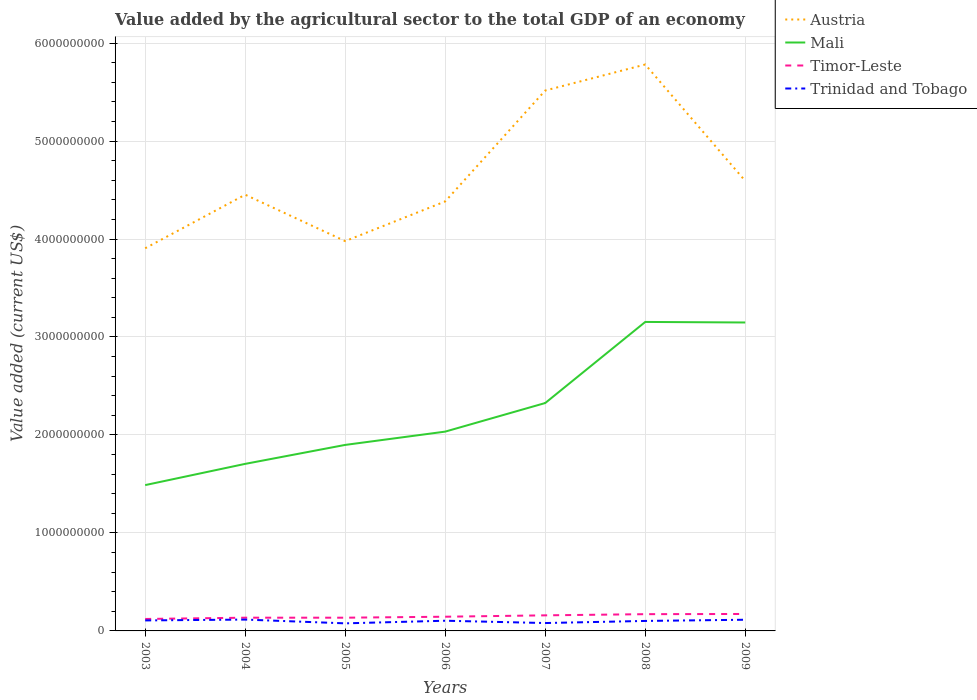How many different coloured lines are there?
Keep it short and to the point. 4. Does the line corresponding to Trinidad and Tobago intersect with the line corresponding to Timor-Leste?
Make the answer very short. No. Is the number of lines equal to the number of legend labels?
Your response must be concise. Yes. Across all years, what is the maximum value added by the agricultural sector to the total GDP in Timor-Leste?
Provide a short and direct response. 1.22e+08. In which year was the value added by the agricultural sector to the total GDP in Austria maximum?
Ensure brevity in your answer.  2003. What is the total value added by the agricultural sector to the total GDP in Austria in the graph?
Keep it short and to the point. -4.05e+08. What is the difference between the highest and the second highest value added by the agricultural sector to the total GDP in Mali?
Make the answer very short. 1.67e+09. Is the value added by the agricultural sector to the total GDP in Trinidad and Tobago strictly greater than the value added by the agricultural sector to the total GDP in Austria over the years?
Your answer should be compact. Yes. How many lines are there?
Ensure brevity in your answer.  4. Are the values on the major ticks of Y-axis written in scientific E-notation?
Your answer should be compact. No. Does the graph contain grids?
Keep it short and to the point. Yes. How many legend labels are there?
Your response must be concise. 4. What is the title of the graph?
Provide a short and direct response. Value added by the agricultural sector to the total GDP of an economy. Does "Greenland" appear as one of the legend labels in the graph?
Offer a very short reply. No. What is the label or title of the X-axis?
Make the answer very short. Years. What is the label or title of the Y-axis?
Keep it short and to the point. Value added (current US$). What is the Value added (current US$) in Austria in 2003?
Keep it short and to the point. 3.91e+09. What is the Value added (current US$) of Mali in 2003?
Your response must be concise. 1.49e+09. What is the Value added (current US$) in Timor-Leste in 2003?
Your answer should be very brief. 1.22e+08. What is the Value added (current US$) of Trinidad and Tobago in 2003?
Make the answer very short. 1.07e+08. What is the Value added (current US$) in Austria in 2004?
Your response must be concise. 4.45e+09. What is the Value added (current US$) of Mali in 2004?
Your answer should be very brief. 1.71e+09. What is the Value added (current US$) of Timor-Leste in 2004?
Provide a succinct answer. 1.35e+08. What is the Value added (current US$) of Trinidad and Tobago in 2004?
Ensure brevity in your answer.  1.16e+08. What is the Value added (current US$) of Austria in 2005?
Offer a terse response. 3.98e+09. What is the Value added (current US$) of Mali in 2005?
Give a very brief answer. 1.90e+09. What is the Value added (current US$) in Timor-Leste in 2005?
Your response must be concise. 1.35e+08. What is the Value added (current US$) in Trinidad and Tobago in 2005?
Provide a short and direct response. 7.73e+07. What is the Value added (current US$) in Austria in 2006?
Your response must be concise. 4.38e+09. What is the Value added (current US$) of Mali in 2006?
Provide a succinct answer. 2.03e+09. What is the Value added (current US$) of Timor-Leste in 2006?
Your answer should be very brief. 1.45e+08. What is the Value added (current US$) in Trinidad and Tobago in 2006?
Your answer should be very brief. 1.04e+08. What is the Value added (current US$) of Austria in 2007?
Give a very brief answer. 5.52e+09. What is the Value added (current US$) of Mali in 2007?
Offer a very short reply. 2.33e+09. What is the Value added (current US$) of Timor-Leste in 2007?
Keep it short and to the point. 1.59e+08. What is the Value added (current US$) in Trinidad and Tobago in 2007?
Keep it short and to the point. 8.04e+07. What is the Value added (current US$) of Austria in 2008?
Give a very brief answer. 5.78e+09. What is the Value added (current US$) of Mali in 2008?
Ensure brevity in your answer.  3.15e+09. What is the Value added (current US$) in Timor-Leste in 2008?
Make the answer very short. 1.71e+08. What is the Value added (current US$) of Trinidad and Tobago in 2008?
Your answer should be compact. 1.02e+08. What is the Value added (current US$) of Austria in 2009?
Your answer should be very brief. 4.59e+09. What is the Value added (current US$) of Mali in 2009?
Your answer should be compact. 3.15e+09. What is the Value added (current US$) in Timor-Leste in 2009?
Offer a terse response. 1.73e+08. What is the Value added (current US$) of Trinidad and Tobago in 2009?
Offer a very short reply. 1.14e+08. Across all years, what is the maximum Value added (current US$) of Austria?
Your answer should be compact. 5.78e+09. Across all years, what is the maximum Value added (current US$) in Mali?
Your answer should be very brief. 3.15e+09. Across all years, what is the maximum Value added (current US$) in Timor-Leste?
Make the answer very short. 1.73e+08. Across all years, what is the maximum Value added (current US$) of Trinidad and Tobago?
Your answer should be very brief. 1.16e+08. Across all years, what is the minimum Value added (current US$) of Austria?
Ensure brevity in your answer.  3.91e+09. Across all years, what is the minimum Value added (current US$) of Mali?
Offer a very short reply. 1.49e+09. Across all years, what is the minimum Value added (current US$) in Timor-Leste?
Your answer should be very brief. 1.22e+08. Across all years, what is the minimum Value added (current US$) in Trinidad and Tobago?
Give a very brief answer. 7.73e+07. What is the total Value added (current US$) of Austria in the graph?
Provide a short and direct response. 3.26e+1. What is the total Value added (current US$) in Mali in the graph?
Give a very brief answer. 1.58e+1. What is the total Value added (current US$) in Timor-Leste in the graph?
Offer a very short reply. 1.04e+09. What is the total Value added (current US$) in Trinidad and Tobago in the graph?
Make the answer very short. 7.01e+08. What is the difference between the Value added (current US$) of Austria in 2003 and that in 2004?
Your answer should be compact. -5.47e+08. What is the difference between the Value added (current US$) of Mali in 2003 and that in 2004?
Ensure brevity in your answer.  -2.17e+08. What is the difference between the Value added (current US$) in Timor-Leste in 2003 and that in 2004?
Offer a terse response. -1.30e+07. What is the difference between the Value added (current US$) of Trinidad and Tobago in 2003 and that in 2004?
Provide a succinct answer. -8.62e+06. What is the difference between the Value added (current US$) of Austria in 2003 and that in 2005?
Offer a very short reply. -7.30e+07. What is the difference between the Value added (current US$) in Mali in 2003 and that in 2005?
Offer a terse response. -4.10e+08. What is the difference between the Value added (current US$) in Timor-Leste in 2003 and that in 2005?
Offer a terse response. -1.30e+07. What is the difference between the Value added (current US$) of Trinidad and Tobago in 2003 and that in 2005?
Provide a short and direct response. 2.99e+07. What is the difference between the Value added (current US$) of Austria in 2003 and that in 2006?
Keep it short and to the point. -4.78e+08. What is the difference between the Value added (current US$) of Mali in 2003 and that in 2006?
Your answer should be compact. -5.46e+08. What is the difference between the Value added (current US$) of Timor-Leste in 2003 and that in 2006?
Give a very brief answer. -2.30e+07. What is the difference between the Value added (current US$) in Trinidad and Tobago in 2003 and that in 2006?
Provide a short and direct response. 3.08e+06. What is the difference between the Value added (current US$) of Austria in 2003 and that in 2007?
Offer a very short reply. -1.61e+09. What is the difference between the Value added (current US$) in Mali in 2003 and that in 2007?
Your answer should be very brief. -8.38e+08. What is the difference between the Value added (current US$) in Timor-Leste in 2003 and that in 2007?
Keep it short and to the point. -3.70e+07. What is the difference between the Value added (current US$) of Trinidad and Tobago in 2003 and that in 2007?
Your response must be concise. 2.67e+07. What is the difference between the Value added (current US$) of Austria in 2003 and that in 2008?
Offer a very short reply. -1.88e+09. What is the difference between the Value added (current US$) of Mali in 2003 and that in 2008?
Provide a succinct answer. -1.67e+09. What is the difference between the Value added (current US$) of Timor-Leste in 2003 and that in 2008?
Make the answer very short. -4.90e+07. What is the difference between the Value added (current US$) of Trinidad and Tobago in 2003 and that in 2008?
Your response must be concise. 5.25e+06. What is the difference between the Value added (current US$) of Austria in 2003 and that in 2009?
Offer a very short reply. -6.87e+08. What is the difference between the Value added (current US$) in Mali in 2003 and that in 2009?
Give a very brief answer. -1.66e+09. What is the difference between the Value added (current US$) of Timor-Leste in 2003 and that in 2009?
Keep it short and to the point. -5.10e+07. What is the difference between the Value added (current US$) of Trinidad and Tobago in 2003 and that in 2009?
Provide a short and direct response. -6.99e+06. What is the difference between the Value added (current US$) of Austria in 2004 and that in 2005?
Provide a short and direct response. 4.74e+08. What is the difference between the Value added (current US$) of Mali in 2004 and that in 2005?
Offer a terse response. -1.94e+08. What is the difference between the Value added (current US$) of Timor-Leste in 2004 and that in 2005?
Provide a succinct answer. 0. What is the difference between the Value added (current US$) of Trinidad and Tobago in 2004 and that in 2005?
Provide a short and direct response. 3.85e+07. What is the difference between the Value added (current US$) in Austria in 2004 and that in 2006?
Keep it short and to the point. 6.86e+07. What is the difference between the Value added (current US$) of Mali in 2004 and that in 2006?
Provide a succinct answer. -3.29e+08. What is the difference between the Value added (current US$) in Timor-Leste in 2004 and that in 2006?
Your answer should be compact. -1.00e+07. What is the difference between the Value added (current US$) in Trinidad and Tobago in 2004 and that in 2006?
Ensure brevity in your answer.  1.17e+07. What is the difference between the Value added (current US$) of Austria in 2004 and that in 2007?
Your answer should be very brief. -1.06e+09. What is the difference between the Value added (current US$) in Mali in 2004 and that in 2007?
Ensure brevity in your answer.  -6.21e+08. What is the difference between the Value added (current US$) in Timor-Leste in 2004 and that in 2007?
Your answer should be very brief. -2.40e+07. What is the difference between the Value added (current US$) in Trinidad and Tobago in 2004 and that in 2007?
Your answer should be very brief. 3.53e+07. What is the difference between the Value added (current US$) of Austria in 2004 and that in 2008?
Ensure brevity in your answer.  -1.33e+09. What is the difference between the Value added (current US$) in Mali in 2004 and that in 2008?
Your answer should be compact. -1.45e+09. What is the difference between the Value added (current US$) of Timor-Leste in 2004 and that in 2008?
Give a very brief answer. -3.60e+07. What is the difference between the Value added (current US$) of Trinidad and Tobago in 2004 and that in 2008?
Offer a very short reply. 1.39e+07. What is the difference between the Value added (current US$) of Austria in 2004 and that in 2009?
Offer a terse response. -1.41e+08. What is the difference between the Value added (current US$) in Mali in 2004 and that in 2009?
Provide a succinct answer. -1.44e+09. What is the difference between the Value added (current US$) in Timor-Leste in 2004 and that in 2009?
Ensure brevity in your answer.  -3.80e+07. What is the difference between the Value added (current US$) in Trinidad and Tobago in 2004 and that in 2009?
Ensure brevity in your answer.  1.63e+06. What is the difference between the Value added (current US$) in Austria in 2005 and that in 2006?
Offer a very short reply. -4.05e+08. What is the difference between the Value added (current US$) of Mali in 2005 and that in 2006?
Your response must be concise. -1.36e+08. What is the difference between the Value added (current US$) of Timor-Leste in 2005 and that in 2006?
Offer a very short reply. -1.00e+07. What is the difference between the Value added (current US$) of Trinidad and Tobago in 2005 and that in 2006?
Make the answer very short. -2.68e+07. What is the difference between the Value added (current US$) in Austria in 2005 and that in 2007?
Provide a short and direct response. -1.54e+09. What is the difference between the Value added (current US$) in Mali in 2005 and that in 2007?
Ensure brevity in your answer.  -4.27e+08. What is the difference between the Value added (current US$) of Timor-Leste in 2005 and that in 2007?
Your answer should be very brief. -2.40e+07. What is the difference between the Value added (current US$) in Trinidad and Tobago in 2005 and that in 2007?
Your answer should be compact. -3.13e+06. What is the difference between the Value added (current US$) of Austria in 2005 and that in 2008?
Make the answer very short. -1.80e+09. What is the difference between the Value added (current US$) of Mali in 2005 and that in 2008?
Make the answer very short. -1.26e+09. What is the difference between the Value added (current US$) of Timor-Leste in 2005 and that in 2008?
Your answer should be compact. -3.60e+07. What is the difference between the Value added (current US$) in Trinidad and Tobago in 2005 and that in 2008?
Keep it short and to the point. -2.46e+07. What is the difference between the Value added (current US$) of Austria in 2005 and that in 2009?
Your answer should be very brief. -6.14e+08. What is the difference between the Value added (current US$) of Mali in 2005 and that in 2009?
Offer a terse response. -1.25e+09. What is the difference between the Value added (current US$) of Timor-Leste in 2005 and that in 2009?
Offer a terse response. -3.80e+07. What is the difference between the Value added (current US$) in Trinidad and Tobago in 2005 and that in 2009?
Your answer should be compact. -3.68e+07. What is the difference between the Value added (current US$) in Austria in 2006 and that in 2007?
Your answer should be very brief. -1.13e+09. What is the difference between the Value added (current US$) of Mali in 2006 and that in 2007?
Ensure brevity in your answer.  -2.92e+08. What is the difference between the Value added (current US$) of Timor-Leste in 2006 and that in 2007?
Provide a succinct answer. -1.40e+07. What is the difference between the Value added (current US$) of Trinidad and Tobago in 2006 and that in 2007?
Your answer should be very brief. 2.36e+07. What is the difference between the Value added (current US$) in Austria in 2006 and that in 2008?
Provide a succinct answer. -1.40e+09. What is the difference between the Value added (current US$) of Mali in 2006 and that in 2008?
Keep it short and to the point. -1.12e+09. What is the difference between the Value added (current US$) of Timor-Leste in 2006 and that in 2008?
Make the answer very short. -2.60e+07. What is the difference between the Value added (current US$) of Trinidad and Tobago in 2006 and that in 2008?
Provide a succinct answer. 2.16e+06. What is the difference between the Value added (current US$) in Austria in 2006 and that in 2009?
Your answer should be compact. -2.09e+08. What is the difference between the Value added (current US$) of Mali in 2006 and that in 2009?
Ensure brevity in your answer.  -1.11e+09. What is the difference between the Value added (current US$) of Timor-Leste in 2006 and that in 2009?
Your answer should be compact. -2.80e+07. What is the difference between the Value added (current US$) in Trinidad and Tobago in 2006 and that in 2009?
Keep it short and to the point. -1.01e+07. What is the difference between the Value added (current US$) in Austria in 2007 and that in 2008?
Provide a succinct answer. -2.65e+08. What is the difference between the Value added (current US$) in Mali in 2007 and that in 2008?
Ensure brevity in your answer.  -8.28e+08. What is the difference between the Value added (current US$) of Timor-Leste in 2007 and that in 2008?
Offer a terse response. -1.20e+07. What is the difference between the Value added (current US$) of Trinidad and Tobago in 2007 and that in 2008?
Make the answer very short. -2.15e+07. What is the difference between the Value added (current US$) in Austria in 2007 and that in 2009?
Give a very brief answer. 9.23e+08. What is the difference between the Value added (current US$) of Mali in 2007 and that in 2009?
Keep it short and to the point. -8.22e+08. What is the difference between the Value added (current US$) in Timor-Leste in 2007 and that in 2009?
Give a very brief answer. -1.40e+07. What is the difference between the Value added (current US$) in Trinidad and Tobago in 2007 and that in 2009?
Your response must be concise. -3.37e+07. What is the difference between the Value added (current US$) in Austria in 2008 and that in 2009?
Your answer should be very brief. 1.19e+09. What is the difference between the Value added (current US$) in Mali in 2008 and that in 2009?
Provide a short and direct response. 5.58e+06. What is the difference between the Value added (current US$) of Trinidad and Tobago in 2008 and that in 2009?
Keep it short and to the point. -1.22e+07. What is the difference between the Value added (current US$) in Austria in 2003 and the Value added (current US$) in Mali in 2004?
Ensure brevity in your answer.  2.20e+09. What is the difference between the Value added (current US$) in Austria in 2003 and the Value added (current US$) in Timor-Leste in 2004?
Offer a very short reply. 3.77e+09. What is the difference between the Value added (current US$) of Austria in 2003 and the Value added (current US$) of Trinidad and Tobago in 2004?
Offer a terse response. 3.79e+09. What is the difference between the Value added (current US$) of Mali in 2003 and the Value added (current US$) of Timor-Leste in 2004?
Make the answer very short. 1.35e+09. What is the difference between the Value added (current US$) in Mali in 2003 and the Value added (current US$) in Trinidad and Tobago in 2004?
Provide a short and direct response. 1.37e+09. What is the difference between the Value added (current US$) of Timor-Leste in 2003 and the Value added (current US$) of Trinidad and Tobago in 2004?
Offer a terse response. 6.22e+06. What is the difference between the Value added (current US$) of Austria in 2003 and the Value added (current US$) of Mali in 2005?
Give a very brief answer. 2.01e+09. What is the difference between the Value added (current US$) in Austria in 2003 and the Value added (current US$) in Timor-Leste in 2005?
Provide a succinct answer. 3.77e+09. What is the difference between the Value added (current US$) in Austria in 2003 and the Value added (current US$) in Trinidad and Tobago in 2005?
Ensure brevity in your answer.  3.83e+09. What is the difference between the Value added (current US$) of Mali in 2003 and the Value added (current US$) of Timor-Leste in 2005?
Offer a very short reply. 1.35e+09. What is the difference between the Value added (current US$) of Mali in 2003 and the Value added (current US$) of Trinidad and Tobago in 2005?
Offer a terse response. 1.41e+09. What is the difference between the Value added (current US$) of Timor-Leste in 2003 and the Value added (current US$) of Trinidad and Tobago in 2005?
Keep it short and to the point. 4.47e+07. What is the difference between the Value added (current US$) of Austria in 2003 and the Value added (current US$) of Mali in 2006?
Your answer should be compact. 1.87e+09. What is the difference between the Value added (current US$) of Austria in 2003 and the Value added (current US$) of Timor-Leste in 2006?
Your answer should be compact. 3.76e+09. What is the difference between the Value added (current US$) of Austria in 2003 and the Value added (current US$) of Trinidad and Tobago in 2006?
Ensure brevity in your answer.  3.80e+09. What is the difference between the Value added (current US$) of Mali in 2003 and the Value added (current US$) of Timor-Leste in 2006?
Make the answer very short. 1.34e+09. What is the difference between the Value added (current US$) in Mali in 2003 and the Value added (current US$) in Trinidad and Tobago in 2006?
Provide a short and direct response. 1.38e+09. What is the difference between the Value added (current US$) of Timor-Leste in 2003 and the Value added (current US$) of Trinidad and Tobago in 2006?
Your answer should be compact. 1.79e+07. What is the difference between the Value added (current US$) of Austria in 2003 and the Value added (current US$) of Mali in 2007?
Your answer should be very brief. 1.58e+09. What is the difference between the Value added (current US$) in Austria in 2003 and the Value added (current US$) in Timor-Leste in 2007?
Provide a succinct answer. 3.75e+09. What is the difference between the Value added (current US$) in Austria in 2003 and the Value added (current US$) in Trinidad and Tobago in 2007?
Your answer should be compact. 3.83e+09. What is the difference between the Value added (current US$) in Mali in 2003 and the Value added (current US$) in Timor-Leste in 2007?
Keep it short and to the point. 1.33e+09. What is the difference between the Value added (current US$) in Mali in 2003 and the Value added (current US$) in Trinidad and Tobago in 2007?
Keep it short and to the point. 1.41e+09. What is the difference between the Value added (current US$) of Timor-Leste in 2003 and the Value added (current US$) of Trinidad and Tobago in 2007?
Provide a succinct answer. 4.16e+07. What is the difference between the Value added (current US$) in Austria in 2003 and the Value added (current US$) in Mali in 2008?
Provide a succinct answer. 7.52e+08. What is the difference between the Value added (current US$) of Austria in 2003 and the Value added (current US$) of Timor-Leste in 2008?
Your answer should be compact. 3.73e+09. What is the difference between the Value added (current US$) of Austria in 2003 and the Value added (current US$) of Trinidad and Tobago in 2008?
Give a very brief answer. 3.80e+09. What is the difference between the Value added (current US$) in Mali in 2003 and the Value added (current US$) in Timor-Leste in 2008?
Keep it short and to the point. 1.32e+09. What is the difference between the Value added (current US$) in Mali in 2003 and the Value added (current US$) in Trinidad and Tobago in 2008?
Offer a very short reply. 1.39e+09. What is the difference between the Value added (current US$) of Timor-Leste in 2003 and the Value added (current US$) of Trinidad and Tobago in 2008?
Offer a very short reply. 2.01e+07. What is the difference between the Value added (current US$) of Austria in 2003 and the Value added (current US$) of Mali in 2009?
Your answer should be very brief. 7.58e+08. What is the difference between the Value added (current US$) in Austria in 2003 and the Value added (current US$) in Timor-Leste in 2009?
Your answer should be very brief. 3.73e+09. What is the difference between the Value added (current US$) in Austria in 2003 and the Value added (current US$) in Trinidad and Tobago in 2009?
Give a very brief answer. 3.79e+09. What is the difference between the Value added (current US$) in Mali in 2003 and the Value added (current US$) in Timor-Leste in 2009?
Make the answer very short. 1.32e+09. What is the difference between the Value added (current US$) in Mali in 2003 and the Value added (current US$) in Trinidad and Tobago in 2009?
Offer a very short reply. 1.37e+09. What is the difference between the Value added (current US$) in Timor-Leste in 2003 and the Value added (current US$) in Trinidad and Tobago in 2009?
Keep it short and to the point. 7.85e+06. What is the difference between the Value added (current US$) in Austria in 2004 and the Value added (current US$) in Mali in 2005?
Make the answer very short. 2.55e+09. What is the difference between the Value added (current US$) of Austria in 2004 and the Value added (current US$) of Timor-Leste in 2005?
Give a very brief answer. 4.32e+09. What is the difference between the Value added (current US$) of Austria in 2004 and the Value added (current US$) of Trinidad and Tobago in 2005?
Provide a succinct answer. 4.37e+09. What is the difference between the Value added (current US$) in Mali in 2004 and the Value added (current US$) in Timor-Leste in 2005?
Make the answer very short. 1.57e+09. What is the difference between the Value added (current US$) of Mali in 2004 and the Value added (current US$) of Trinidad and Tobago in 2005?
Provide a succinct answer. 1.63e+09. What is the difference between the Value added (current US$) of Timor-Leste in 2004 and the Value added (current US$) of Trinidad and Tobago in 2005?
Your answer should be compact. 5.77e+07. What is the difference between the Value added (current US$) in Austria in 2004 and the Value added (current US$) in Mali in 2006?
Provide a succinct answer. 2.42e+09. What is the difference between the Value added (current US$) in Austria in 2004 and the Value added (current US$) in Timor-Leste in 2006?
Your response must be concise. 4.31e+09. What is the difference between the Value added (current US$) of Austria in 2004 and the Value added (current US$) of Trinidad and Tobago in 2006?
Keep it short and to the point. 4.35e+09. What is the difference between the Value added (current US$) in Mali in 2004 and the Value added (current US$) in Timor-Leste in 2006?
Ensure brevity in your answer.  1.56e+09. What is the difference between the Value added (current US$) in Mali in 2004 and the Value added (current US$) in Trinidad and Tobago in 2006?
Offer a very short reply. 1.60e+09. What is the difference between the Value added (current US$) in Timor-Leste in 2004 and the Value added (current US$) in Trinidad and Tobago in 2006?
Provide a short and direct response. 3.09e+07. What is the difference between the Value added (current US$) in Austria in 2004 and the Value added (current US$) in Mali in 2007?
Your response must be concise. 2.13e+09. What is the difference between the Value added (current US$) of Austria in 2004 and the Value added (current US$) of Timor-Leste in 2007?
Ensure brevity in your answer.  4.29e+09. What is the difference between the Value added (current US$) in Austria in 2004 and the Value added (current US$) in Trinidad and Tobago in 2007?
Provide a succinct answer. 4.37e+09. What is the difference between the Value added (current US$) of Mali in 2004 and the Value added (current US$) of Timor-Leste in 2007?
Keep it short and to the point. 1.55e+09. What is the difference between the Value added (current US$) in Mali in 2004 and the Value added (current US$) in Trinidad and Tobago in 2007?
Your response must be concise. 1.62e+09. What is the difference between the Value added (current US$) in Timor-Leste in 2004 and the Value added (current US$) in Trinidad and Tobago in 2007?
Make the answer very short. 5.46e+07. What is the difference between the Value added (current US$) in Austria in 2004 and the Value added (current US$) in Mali in 2008?
Your response must be concise. 1.30e+09. What is the difference between the Value added (current US$) of Austria in 2004 and the Value added (current US$) of Timor-Leste in 2008?
Offer a terse response. 4.28e+09. What is the difference between the Value added (current US$) of Austria in 2004 and the Value added (current US$) of Trinidad and Tobago in 2008?
Provide a succinct answer. 4.35e+09. What is the difference between the Value added (current US$) of Mali in 2004 and the Value added (current US$) of Timor-Leste in 2008?
Offer a terse response. 1.53e+09. What is the difference between the Value added (current US$) of Mali in 2004 and the Value added (current US$) of Trinidad and Tobago in 2008?
Provide a succinct answer. 1.60e+09. What is the difference between the Value added (current US$) in Timor-Leste in 2004 and the Value added (current US$) in Trinidad and Tobago in 2008?
Offer a very short reply. 3.31e+07. What is the difference between the Value added (current US$) of Austria in 2004 and the Value added (current US$) of Mali in 2009?
Make the answer very short. 1.30e+09. What is the difference between the Value added (current US$) in Austria in 2004 and the Value added (current US$) in Timor-Leste in 2009?
Keep it short and to the point. 4.28e+09. What is the difference between the Value added (current US$) of Austria in 2004 and the Value added (current US$) of Trinidad and Tobago in 2009?
Give a very brief answer. 4.34e+09. What is the difference between the Value added (current US$) in Mali in 2004 and the Value added (current US$) in Timor-Leste in 2009?
Provide a succinct answer. 1.53e+09. What is the difference between the Value added (current US$) of Mali in 2004 and the Value added (current US$) of Trinidad and Tobago in 2009?
Offer a terse response. 1.59e+09. What is the difference between the Value added (current US$) in Timor-Leste in 2004 and the Value added (current US$) in Trinidad and Tobago in 2009?
Make the answer very short. 2.08e+07. What is the difference between the Value added (current US$) of Austria in 2005 and the Value added (current US$) of Mali in 2006?
Ensure brevity in your answer.  1.94e+09. What is the difference between the Value added (current US$) of Austria in 2005 and the Value added (current US$) of Timor-Leste in 2006?
Your answer should be very brief. 3.83e+09. What is the difference between the Value added (current US$) of Austria in 2005 and the Value added (current US$) of Trinidad and Tobago in 2006?
Provide a short and direct response. 3.87e+09. What is the difference between the Value added (current US$) of Mali in 2005 and the Value added (current US$) of Timor-Leste in 2006?
Give a very brief answer. 1.75e+09. What is the difference between the Value added (current US$) of Mali in 2005 and the Value added (current US$) of Trinidad and Tobago in 2006?
Offer a terse response. 1.79e+09. What is the difference between the Value added (current US$) of Timor-Leste in 2005 and the Value added (current US$) of Trinidad and Tobago in 2006?
Make the answer very short. 3.09e+07. What is the difference between the Value added (current US$) in Austria in 2005 and the Value added (current US$) in Mali in 2007?
Keep it short and to the point. 1.65e+09. What is the difference between the Value added (current US$) in Austria in 2005 and the Value added (current US$) in Timor-Leste in 2007?
Make the answer very short. 3.82e+09. What is the difference between the Value added (current US$) of Austria in 2005 and the Value added (current US$) of Trinidad and Tobago in 2007?
Ensure brevity in your answer.  3.90e+09. What is the difference between the Value added (current US$) of Mali in 2005 and the Value added (current US$) of Timor-Leste in 2007?
Make the answer very short. 1.74e+09. What is the difference between the Value added (current US$) in Mali in 2005 and the Value added (current US$) in Trinidad and Tobago in 2007?
Provide a short and direct response. 1.82e+09. What is the difference between the Value added (current US$) in Timor-Leste in 2005 and the Value added (current US$) in Trinidad and Tobago in 2007?
Keep it short and to the point. 5.46e+07. What is the difference between the Value added (current US$) of Austria in 2005 and the Value added (current US$) of Mali in 2008?
Make the answer very short. 8.25e+08. What is the difference between the Value added (current US$) in Austria in 2005 and the Value added (current US$) in Timor-Leste in 2008?
Your response must be concise. 3.81e+09. What is the difference between the Value added (current US$) of Austria in 2005 and the Value added (current US$) of Trinidad and Tobago in 2008?
Your response must be concise. 3.88e+09. What is the difference between the Value added (current US$) of Mali in 2005 and the Value added (current US$) of Timor-Leste in 2008?
Make the answer very short. 1.73e+09. What is the difference between the Value added (current US$) of Mali in 2005 and the Value added (current US$) of Trinidad and Tobago in 2008?
Your answer should be compact. 1.80e+09. What is the difference between the Value added (current US$) of Timor-Leste in 2005 and the Value added (current US$) of Trinidad and Tobago in 2008?
Your answer should be very brief. 3.31e+07. What is the difference between the Value added (current US$) of Austria in 2005 and the Value added (current US$) of Mali in 2009?
Keep it short and to the point. 8.31e+08. What is the difference between the Value added (current US$) of Austria in 2005 and the Value added (current US$) of Timor-Leste in 2009?
Offer a very short reply. 3.81e+09. What is the difference between the Value added (current US$) of Austria in 2005 and the Value added (current US$) of Trinidad and Tobago in 2009?
Provide a short and direct response. 3.86e+09. What is the difference between the Value added (current US$) in Mali in 2005 and the Value added (current US$) in Timor-Leste in 2009?
Your answer should be compact. 1.73e+09. What is the difference between the Value added (current US$) of Mali in 2005 and the Value added (current US$) of Trinidad and Tobago in 2009?
Offer a terse response. 1.78e+09. What is the difference between the Value added (current US$) in Timor-Leste in 2005 and the Value added (current US$) in Trinidad and Tobago in 2009?
Provide a short and direct response. 2.08e+07. What is the difference between the Value added (current US$) of Austria in 2006 and the Value added (current US$) of Mali in 2007?
Give a very brief answer. 2.06e+09. What is the difference between the Value added (current US$) in Austria in 2006 and the Value added (current US$) in Timor-Leste in 2007?
Keep it short and to the point. 4.22e+09. What is the difference between the Value added (current US$) of Austria in 2006 and the Value added (current US$) of Trinidad and Tobago in 2007?
Offer a very short reply. 4.30e+09. What is the difference between the Value added (current US$) in Mali in 2006 and the Value added (current US$) in Timor-Leste in 2007?
Give a very brief answer. 1.88e+09. What is the difference between the Value added (current US$) in Mali in 2006 and the Value added (current US$) in Trinidad and Tobago in 2007?
Your answer should be compact. 1.95e+09. What is the difference between the Value added (current US$) of Timor-Leste in 2006 and the Value added (current US$) of Trinidad and Tobago in 2007?
Make the answer very short. 6.46e+07. What is the difference between the Value added (current US$) in Austria in 2006 and the Value added (current US$) in Mali in 2008?
Your response must be concise. 1.23e+09. What is the difference between the Value added (current US$) of Austria in 2006 and the Value added (current US$) of Timor-Leste in 2008?
Provide a succinct answer. 4.21e+09. What is the difference between the Value added (current US$) of Austria in 2006 and the Value added (current US$) of Trinidad and Tobago in 2008?
Offer a terse response. 4.28e+09. What is the difference between the Value added (current US$) of Mali in 2006 and the Value added (current US$) of Timor-Leste in 2008?
Ensure brevity in your answer.  1.86e+09. What is the difference between the Value added (current US$) of Mali in 2006 and the Value added (current US$) of Trinidad and Tobago in 2008?
Ensure brevity in your answer.  1.93e+09. What is the difference between the Value added (current US$) of Timor-Leste in 2006 and the Value added (current US$) of Trinidad and Tobago in 2008?
Offer a terse response. 4.31e+07. What is the difference between the Value added (current US$) of Austria in 2006 and the Value added (current US$) of Mali in 2009?
Your response must be concise. 1.24e+09. What is the difference between the Value added (current US$) in Austria in 2006 and the Value added (current US$) in Timor-Leste in 2009?
Your answer should be compact. 4.21e+09. What is the difference between the Value added (current US$) of Austria in 2006 and the Value added (current US$) of Trinidad and Tobago in 2009?
Your response must be concise. 4.27e+09. What is the difference between the Value added (current US$) in Mali in 2006 and the Value added (current US$) in Timor-Leste in 2009?
Give a very brief answer. 1.86e+09. What is the difference between the Value added (current US$) of Mali in 2006 and the Value added (current US$) of Trinidad and Tobago in 2009?
Make the answer very short. 1.92e+09. What is the difference between the Value added (current US$) in Timor-Leste in 2006 and the Value added (current US$) in Trinidad and Tobago in 2009?
Your answer should be very brief. 3.08e+07. What is the difference between the Value added (current US$) of Austria in 2007 and the Value added (current US$) of Mali in 2008?
Your response must be concise. 2.36e+09. What is the difference between the Value added (current US$) in Austria in 2007 and the Value added (current US$) in Timor-Leste in 2008?
Provide a short and direct response. 5.34e+09. What is the difference between the Value added (current US$) of Austria in 2007 and the Value added (current US$) of Trinidad and Tobago in 2008?
Ensure brevity in your answer.  5.41e+09. What is the difference between the Value added (current US$) of Mali in 2007 and the Value added (current US$) of Timor-Leste in 2008?
Give a very brief answer. 2.16e+09. What is the difference between the Value added (current US$) of Mali in 2007 and the Value added (current US$) of Trinidad and Tobago in 2008?
Your answer should be very brief. 2.22e+09. What is the difference between the Value added (current US$) in Timor-Leste in 2007 and the Value added (current US$) in Trinidad and Tobago in 2008?
Make the answer very short. 5.71e+07. What is the difference between the Value added (current US$) in Austria in 2007 and the Value added (current US$) in Mali in 2009?
Your response must be concise. 2.37e+09. What is the difference between the Value added (current US$) of Austria in 2007 and the Value added (current US$) of Timor-Leste in 2009?
Your response must be concise. 5.34e+09. What is the difference between the Value added (current US$) in Austria in 2007 and the Value added (current US$) in Trinidad and Tobago in 2009?
Offer a terse response. 5.40e+09. What is the difference between the Value added (current US$) in Mali in 2007 and the Value added (current US$) in Timor-Leste in 2009?
Your response must be concise. 2.15e+09. What is the difference between the Value added (current US$) of Mali in 2007 and the Value added (current US$) of Trinidad and Tobago in 2009?
Your answer should be very brief. 2.21e+09. What is the difference between the Value added (current US$) in Timor-Leste in 2007 and the Value added (current US$) in Trinidad and Tobago in 2009?
Provide a succinct answer. 4.48e+07. What is the difference between the Value added (current US$) in Austria in 2008 and the Value added (current US$) in Mali in 2009?
Provide a succinct answer. 2.63e+09. What is the difference between the Value added (current US$) in Austria in 2008 and the Value added (current US$) in Timor-Leste in 2009?
Make the answer very short. 5.61e+09. What is the difference between the Value added (current US$) in Austria in 2008 and the Value added (current US$) in Trinidad and Tobago in 2009?
Provide a short and direct response. 5.67e+09. What is the difference between the Value added (current US$) in Mali in 2008 and the Value added (current US$) in Timor-Leste in 2009?
Provide a short and direct response. 2.98e+09. What is the difference between the Value added (current US$) in Mali in 2008 and the Value added (current US$) in Trinidad and Tobago in 2009?
Your answer should be compact. 3.04e+09. What is the difference between the Value added (current US$) in Timor-Leste in 2008 and the Value added (current US$) in Trinidad and Tobago in 2009?
Give a very brief answer. 5.68e+07. What is the average Value added (current US$) in Austria per year?
Offer a very short reply. 4.66e+09. What is the average Value added (current US$) of Mali per year?
Give a very brief answer. 2.25e+09. What is the average Value added (current US$) of Timor-Leste per year?
Ensure brevity in your answer.  1.49e+08. What is the average Value added (current US$) in Trinidad and Tobago per year?
Give a very brief answer. 1.00e+08. In the year 2003, what is the difference between the Value added (current US$) in Austria and Value added (current US$) in Mali?
Make the answer very short. 2.42e+09. In the year 2003, what is the difference between the Value added (current US$) in Austria and Value added (current US$) in Timor-Leste?
Offer a terse response. 3.78e+09. In the year 2003, what is the difference between the Value added (current US$) in Austria and Value added (current US$) in Trinidad and Tobago?
Offer a very short reply. 3.80e+09. In the year 2003, what is the difference between the Value added (current US$) of Mali and Value added (current US$) of Timor-Leste?
Offer a very short reply. 1.37e+09. In the year 2003, what is the difference between the Value added (current US$) of Mali and Value added (current US$) of Trinidad and Tobago?
Provide a succinct answer. 1.38e+09. In the year 2003, what is the difference between the Value added (current US$) in Timor-Leste and Value added (current US$) in Trinidad and Tobago?
Provide a succinct answer. 1.48e+07. In the year 2004, what is the difference between the Value added (current US$) of Austria and Value added (current US$) of Mali?
Your response must be concise. 2.75e+09. In the year 2004, what is the difference between the Value added (current US$) in Austria and Value added (current US$) in Timor-Leste?
Your answer should be very brief. 4.32e+09. In the year 2004, what is the difference between the Value added (current US$) of Austria and Value added (current US$) of Trinidad and Tobago?
Your answer should be very brief. 4.34e+09. In the year 2004, what is the difference between the Value added (current US$) in Mali and Value added (current US$) in Timor-Leste?
Keep it short and to the point. 1.57e+09. In the year 2004, what is the difference between the Value added (current US$) in Mali and Value added (current US$) in Trinidad and Tobago?
Your answer should be compact. 1.59e+09. In the year 2004, what is the difference between the Value added (current US$) in Timor-Leste and Value added (current US$) in Trinidad and Tobago?
Offer a terse response. 1.92e+07. In the year 2005, what is the difference between the Value added (current US$) in Austria and Value added (current US$) in Mali?
Offer a terse response. 2.08e+09. In the year 2005, what is the difference between the Value added (current US$) of Austria and Value added (current US$) of Timor-Leste?
Your answer should be very brief. 3.84e+09. In the year 2005, what is the difference between the Value added (current US$) of Austria and Value added (current US$) of Trinidad and Tobago?
Provide a succinct answer. 3.90e+09. In the year 2005, what is the difference between the Value added (current US$) of Mali and Value added (current US$) of Timor-Leste?
Your answer should be compact. 1.76e+09. In the year 2005, what is the difference between the Value added (current US$) in Mali and Value added (current US$) in Trinidad and Tobago?
Your answer should be very brief. 1.82e+09. In the year 2005, what is the difference between the Value added (current US$) in Timor-Leste and Value added (current US$) in Trinidad and Tobago?
Your answer should be compact. 5.77e+07. In the year 2006, what is the difference between the Value added (current US$) of Austria and Value added (current US$) of Mali?
Give a very brief answer. 2.35e+09. In the year 2006, what is the difference between the Value added (current US$) of Austria and Value added (current US$) of Timor-Leste?
Your answer should be compact. 4.24e+09. In the year 2006, what is the difference between the Value added (current US$) in Austria and Value added (current US$) in Trinidad and Tobago?
Give a very brief answer. 4.28e+09. In the year 2006, what is the difference between the Value added (current US$) in Mali and Value added (current US$) in Timor-Leste?
Your response must be concise. 1.89e+09. In the year 2006, what is the difference between the Value added (current US$) of Mali and Value added (current US$) of Trinidad and Tobago?
Offer a terse response. 1.93e+09. In the year 2006, what is the difference between the Value added (current US$) of Timor-Leste and Value added (current US$) of Trinidad and Tobago?
Your answer should be compact. 4.09e+07. In the year 2007, what is the difference between the Value added (current US$) of Austria and Value added (current US$) of Mali?
Your answer should be very brief. 3.19e+09. In the year 2007, what is the difference between the Value added (current US$) of Austria and Value added (current US$) of Timor-Leste?
Provide a short and direct response. 5.36e+09. In the year 2007, what is the difference between the Value added (current US$) of Austria and Value added (current US$) of Trinidad and Tobago?
Give a very brief answer. 5.44e+09. In the year 2007, what is the difference between the Value added (current US$) of Mali and Value added (current US$) of Timor-Leste?
Give a very brief answer. 2.17e+09. In the year 2007, what is the difference between the Value added (current US$) of Mali and Value added (current US$) of Trinidad and Tobago?
Offer a terse response. 2.25e+09. In the year 2007, what is the difference between the Value added (current US$) in Timor-Leste and Value added (current US$) in Trinidad and Tobago?
Provide a succinct answer. 7.86e+07. In the year 2008, what is the difference between the Value added (current US$) of Austria and Value added (current US$) of Mali?
Make the answer very short. 2.63e+09. In the year 2008, what is the difference between the Value added (current US$) in Austria and Value added (current US$) in Timor-Leste?
Keep it short and to the point. 5.61e+09. In the year 2008, what is the difference between the Value added (current US$) of Austria and Value added (current US$) of Trinidad and Tobago?
Offer a terse response. 5.68e+09. In the year 2008, what is the difference between the Value added (current US$) in Mali and Value added (current US$) in Timor-Leste?
Make the answer very short. 2.98e+09. In the year 2008, what is the difference between the Value added (current US$) of Mali and Value added (current US$) of Trinidad and Tobago?
Your answer should be very brief. 3.05e+09. In the year 2008, what is the difference between the Value added (current US$) of Timor-Leste and Value added (current US$) of Trinidad and Tobago?
Offer a very short reply. 6.91e+07. In the year 2009, what is the difference between the Value added (current US$) of Austria and Value added (current US$) of Mali?
Provide a succinct answer. 1.45e+09. In the year 2009, what is the difference between the Value added (current US$) in Austria and Value added (current US$) in Timor-Leste?
Your answer should be very brief. 4.42e+09. In the year 2009, what is the difference between the Value added (current US$) of Austria and Value added (current US$) of Trinidad and Tobago?
Your answer should be very brief. 4.48e+09. In the year 2009, what is the difference between the Value added (current US$) in Mali and Value added (current US$) in Timor-Leste?
Keep it short and to the point. 2.98e+09. In the year 2009, what is the difference between the Value added (current US$) of Mali and Value added (current US$) of Trinidad and Tobago?
Your response must be concise. 3.03e+09. In the year 2009, what is the difference between the Value added (current US$) in Timor-Leste and Value added (current US$) in Trinidad and Tobago?
Make the answer very short. 5.88e+07. What is the ratio of the Value added (current US$) of Austria in 2003 to that in 2004?
Make the answer very short. 0.88. What is the ratio of the Value added (current US$) of Mali in 2003 to that in 2004?
Make the answer very short. 0.87. What is the ratio of the Value added (current US$) of Timor-Leste in 2003 to that in 2004?
Keep it short and to the point. 0.9. What is the ratio of the Value added (current US$) in Trinidad and Tobago in 2003 to that in 2004?
Offer a terse response. 0.93. What is the ratio of the Value added (current US$) in Austria in 2003 to that in 2005?
Your answer should be very brief. 0.98. What is the ratio of the Value added (current US$) of Mali in 2003 to that in 2005?
Keep it short and to the point. 0.78. What is the ratio of the Value added (current US$) of Timor-Leste in 2003 to that in 2005?
Provide a short and direct response. 0.9. What is the ratio of the Value added (current US$) of Trinidad and Tobago in 2003 to that in 2005?
Your response must be concise. 1.39. What is the ratio of the Value added (current US$) of Austria in 2003 to that in 2006?
Your answer should be compact. 0.89. What is the ratio of the Value added (current US$) of Mali in 2003 to that in 2006?
Give a very brief answer. 0.73. What is the ratio of the Value added (current US$) in Timor-Leste in 2003 to that in 2006?
Offer a very short reply. 0.84. What is the ratio of the Value added (current US$) in Trinidad and Tobago in 2003 to that in 2006?
Provide a succinct answer. 1.03. What is the ratio of the Value added (current US$) of Austria in 2003 to that in 2007?
Your answer should be very brief. 0.71. What is the ratio of the Value added (current US$) in Mali in 2003 to that in 2007?
Offer a very short reply. 0.64. What is the ratio of the Value added (current US$) in Timor-Leste in 2003 to that in 2007?
Offer a terse response. 0.77. What is the ratio of the Value added (current US$) of Trinidad and Tobago in 2003 to that in 2007?
Your response must be concise. 1.33. What is the ratio of the Value added (current US$) of Austria in 2003 to that in 2008?
Provide a succinct answer. 0.68. What is the ratio of the Value added (current US$) of Mali in 2003 to that in 2008?
Your answer should be compact. 0.47. What is the ratio of the Value added (current US$) of Timor-Leste in 2003 to that in 2008?
Offer a terse response. 0.71. What is the ratio of the Value added (current US$) of Trinidad and Tobago in 2003 to that in 2008?
Keep it short and to the point. 1.05. What is the ratio of the Value added (current US$) in Austria in 2003 to that in 2009?
Offer a very short reply. 0.85. What is the ratio of the Value added (current US$) in Mali in 2003 to that in 2009?
Make the answer very short. 0.47. What is the ratio of the Value added (current US$) in Timor-Leste in 2003 to that in 2009?
Provide a succinct answer. 0.71. What is the ratio of the Value added (current US$) of Trinidad and Tobago in 2003 to that in 2009?
Your response must be concise. 0.94. What is the ratio of the Value added (current US$) of Austria in 2004 to that in 2005?
Offer a very short reply. 1.12. What is the ratio of the Value added (current US$) of Mali in 2004 to that in 2005?
Make the answer very short. 0.9. What is the ratio of the Value added (current US$) of Timor-Leste in 2004 to that in 2005?
Keep it short and to the point. 1. What is the ratio of the Value added (current US$) in Trinidad and Tobago in 2004 to that in 2005?
Offer a very short reply. 1.5. What is the ratio of the Value added (current US$) of Austria in 2004 to that in 2006?
Your response must be concise. 1.02. What is the ratio of the Value added (current US$) in Mali in 2004 to that in 2006?
Make the answer very short. 0.84. What is the ratio of the Value added (current US$) of Trinidad and Tobago in 2004 to that in 2006?
Your answer should be compact. 1.11. What is the ratio of the Value added (current US$) of Austria in 2004 to that in 2007?
Your answer should be very brief. 0.81. What is the ratio of the Value added (current US$) of Mali in 2004 to that in 2007?
Offer a terse response. 0.73. What is the ratio of the Value added (current US$) in Timor-Leste in 2004 to that in 2007?
Offer a very short reply. 0.85. What is the ratio of the Value added (current US$) of Trinidad and Tobago in 2004 to that in 2007?
Your answer should be very brief. 1.44. What is the ratio of the Value added (current US$) in Austria in 2004 to that in 2008?
Your answer should be very brief. 0.77. What is the ratio of the Value added (current US$) in Mali in 2004 to that in 2008?
Your answer should be very brief. 0.54. What is the ratio of the Value added (current US$) in Timor-Leste in 2004 to that in 2008?
Keep it short and to the point. 0.79. What is the ratio of the Value added (current US$) of Trinidad and Tobago in 2004 to that in 2008?
Your response must be concise. 1.14. What is the ratio of the Value added (current US$) in Austria in 2004 to that in 2009?
Your answer should be very brief. 0.97. What is the ratio of the Value added (current US$) of Mali in 2004 to that in 2009?
Make the answer very short. 0.54. What is the ratio of the Value added (current US$) in Timor-Leste in 2004 to that in 2009?
Provide a short and direct response. 0.78. What is the ratio of the Value added (current US$) of Trinidad and Tobago in 2004 to that in 2009?
Offer a terse response. 1.01. What is the ratio of the Value added (current US$) of Austria in 2005 to that in 2006?
Keep it short and to the point. 0.91. What is the ratio of the Value added (current US$) in Mali in 2005 to that in 2006?
Make the answer very short. 0.93. What is the ratio of the Value added (current US$) in Timor-Leste in 2005 to that in 2006?
Keep it short and to the point. 0.93. What is the ratio of the Value added (current US$) of Trinidad and Tobago in 2005 to that in 2006?
Your answer should be very brief. 0.74. What is the ratio of the Value added (current US$) in Austria in 2005 to that in 2007?
Keep it short and to the point. 0.72. What is the ratio of the Value added (current US$) in Mali in 2005 to that in 2007?
Offer a terse response. 0.82. What is the ratio of the Value added (current US$) in Timor-Leste in 2005 to that in 2007?
Offer a very short reply. 0.85. What is the ratio of the Value added (current US$) of Trinidad and Tobago in 2005 to that in 2007?
Ensure brevity in your answer.  0.96. What is the ratio of the Value added (current US$) of Austria in 2005 to that in 2008?
Your answer should be compact. 0.69. What is the ratio of the Value added (current US$) of Mali in 2005 to that in 2008?
Your answer should be compact. 0.6. What is the ratio of the Value added (current US$) of Timor-Leste in 2005 to that in 2008?
Make the answer very short. 0.79. What is the ratio of the Value added (current US$) of Trinidad and Tobago in 2005 to that in 2008?
Provide a succinct answer. 0.76. What is the ratio of the Value added (current US$) of Austria in 2005 to that in 2009?
Give a very brief answer. 0.87. What is the ratio of the Value added (current US$) of Mali in 2005 to that in 2009?
Your answer should be compact. 0.6. What is the ratio of the Value added (current US$) in Timor-Leste in 2005 to that in 2009?
Ensure brevity in your answer.  0.78. What is the ratio of the Value added (current US$) in Trinidad and Tobago in 2005 to that in 2009?
Your response must be concise. 0.68. What is the ratio of the Value added (current US$) of Austria in 2006 to that in 2007?
Keep it short and to the point. 0.79. What is the ratio of the Value added (current US$) of Mali in 2006 to that in 2007?
Give a very brief answer. 0.87. What is the ratio of the Value added (current US$) in Timor-Leste in 2006 to that in 2007?
Your response must be concise. 0.91. What is the ratio of the Value added (current US$) in Trinidad and Tobago in 2006 to that in 2007?
Provide a short and direct response. 1.29. What is the ratio of the Value added (current US$) of Austria in 2006 to that in 2008?
Your answer should be very brief. 0.76. What is the ratio of the Value added (current US$) of Mali in 2006 to that in 2008?
Give a very brief answer. 0.65. What is the ratio of the Value added (current US$) of Timor-Leste in 2006 to that in 2008?
Keep it short and to the point. 0.85. What is the ratio of the Value added (current US$) in Trinidad and Tobago in 2006 to that in 2008?
Give a very brief answer. 1.02. What is the ratio of the Value added (current US$) of Austria in 2006 to that in 2009?
Give a very brief answer. 0.95. What is the ratio of the Value added (current US$) in Mali in 2006 to that in 2009?
Offer a very short reply. 0.65. What is the ratio of the Value added (current US$) in Timor-Leste in 2006 to that in 2009?
Your answer should be very brief. 0.84. What is the ratio of the Value added (current US$) in Trinidad and Tobago in 2006 to that in 2009?
Provide a short and direct response. 0.91. What is the ratio of the Value added (current US$) of Austria in 2007 to that in 2008?
Provide a succinct answer. 0.95. What is the ratio of the Value added (current US$) in Mali in 2007 to that in 2008?
Your answer should be very brief. 0.74. What is the ratio of the Value added (current US$) of Timor-Leste in 2007 to that in 2008?
Ensure brevity in your answer.  0.93. What is the ratio of the Value added (current US$) in Trinidad and Tobago in 2007 to that in 2008?
Your response must be concise. 0.79. What is the ratio of the Value added (current US$) of Austria in 2007 to that in 2009?
Offer a terse response. 1.2. What is the ratio of the Value added (current US$) of Mali in 2007 to that in 2009?
Give a very brief answer. 0.74. What is the ratio of the Value added (current US$) of Timor-Leste in 2007 to that in 2009?
Your answer should be very brief. 0.92. What is the ratio of the Value added (current US$) in Trinidad and Tobago in 2007 to that in 2009?
Ensure brevity in your answer.  0.7. What is the ratio of the Value added (current US$) of Austria in 2008 to that in 2009?
Keep it short and to the point. 1.26. What is the ratio of the Value added (current US$) in Mali in 2008 to that in 2009?
Keep it short and to the point. 1. What is the ratio of the Value added (current US$) in Timor-Leste in 2008 to that in 2009?
Your answer should be compact. 0.99. What is the ratio of the Value added (current US$) in Trinidad and Tobago in 2008 to that in 2009?
Provide a succinct answer. 0.89. What is the difference between the highest and the second highest Value added (current US$) in Austria?
Ensure brevity in your answer.  2.65e+08. What is the difference between the highest and the second highest Value added (current US$) of Mali?
Offer a very short reply. 5.58e+06. What is the difference between the highest and the second highest Value added (current US$) in Trinidad and Tobago?
Give a very brief answer. 1.63e+06. What is the difference between the highest and the lowest Value added (current US$) of Austria?
Provide a succinct answer. 1.88e+09. What is the difference between the highest and the lowest Value added (current US$) in Mali?
Ensure brevity in your answer.  1.67e+09. What is the difference between the highest and the lowest Value added (current US$) of Timor-Leste?
Give a very brief answer. 5.10e+07. What is the difference between the highest and the lowest Value added (current US$) of Trinidad and Tobago?
Provide a succinct answer. 3.85e+07. 